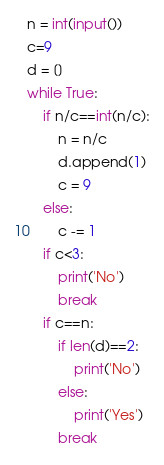<code> <loc_0><loc_0><loc_500><loc_500><_Python_>n = int(input())
c=9
d = []
while True:
    if n/c==int(n/c):
        n = n/c
        d.append(1)
        c = 9
    else:
        c -= 1
    if c<3:
        print('No')
        break
    if c==n:
        if len(d)==2:
            print('No')
        else:
            print('Yes')
        break</code> 